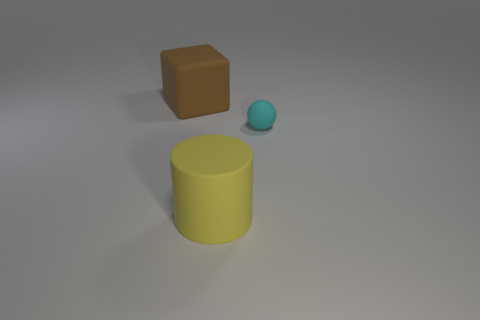Subtract 1 balls. How many balls are left? 0 Add 3 small brown shiny things. How many objects exist? 6 Subtract all cubes. How many objects are left? 2 Add 2 large blue rubber cylinders. How many large blue rubber cylinders exist? 2 Subtract 0 green cylinders. How many objects are left? 3 Subtract all big yellow rubber things. Subtract all tiny matte balls. How many objects are left? 1 Add 2 yellow matte cylinders. How many yellow matte cylinders are left? 3 